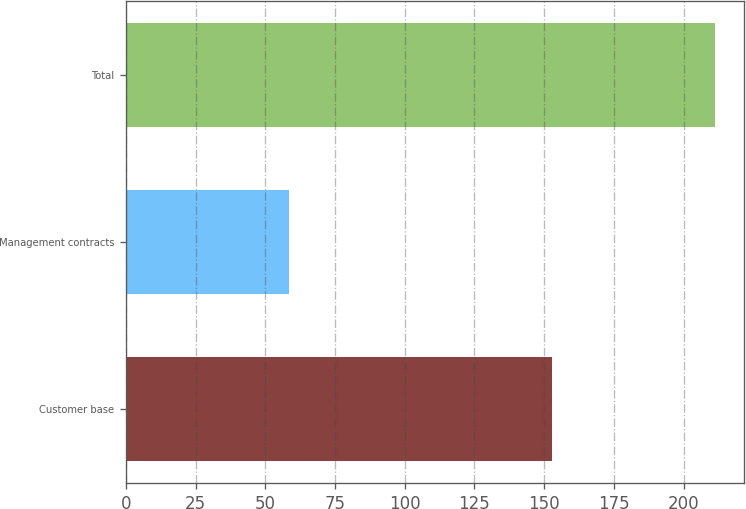Convert chart to OTSL. <chart><loc_0><loc_0><loc_500><loc_500><bar_chart><fcel>Customer base<fcel>Management contracts<fcel>Total<nl><fcel>152.7<fcel>58.6<fcel>211.3<nl></chart> 